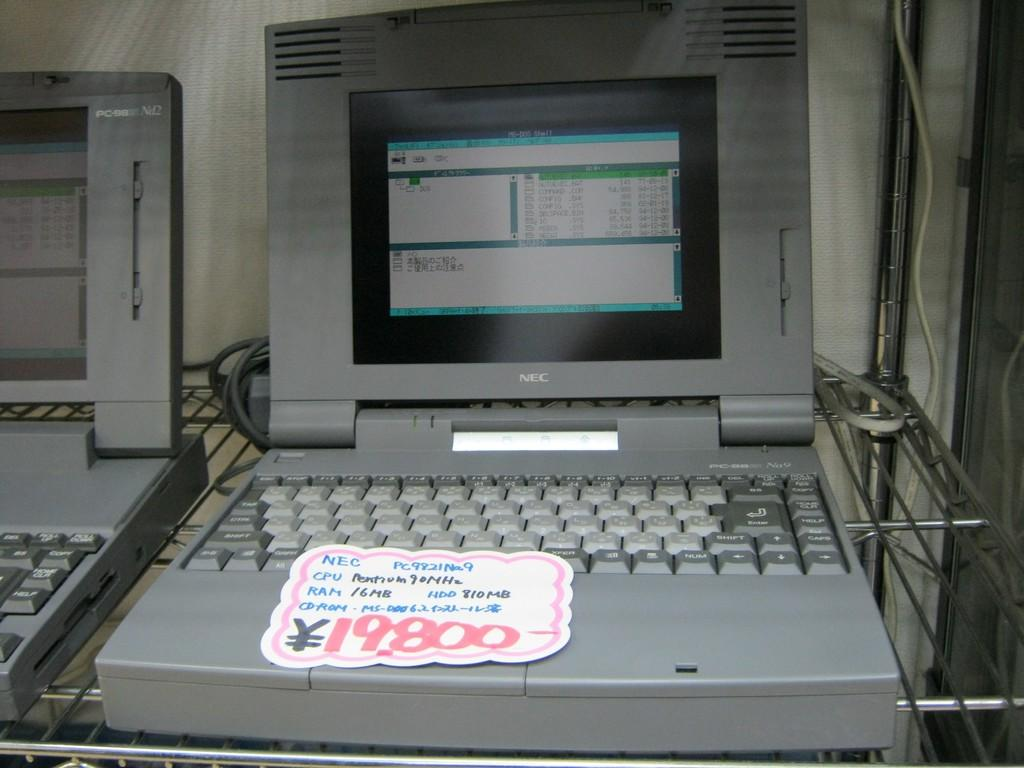<image>
Write a terse but informative summary of the picture. A grey laptop is on a shelf and has a price tag on it of 19800. 